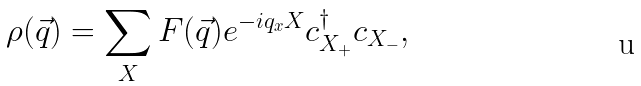<formula> <loc_0><loc_0><loc_500><loc_500>\rho ( \vec { q } ) = \sum _ { X } F ( \vec { q } ) e ^ { - i q _ { x } X } c ^ { \dagger } _ { X _ { + } } c _ { X _ { - } } ,</formula> 